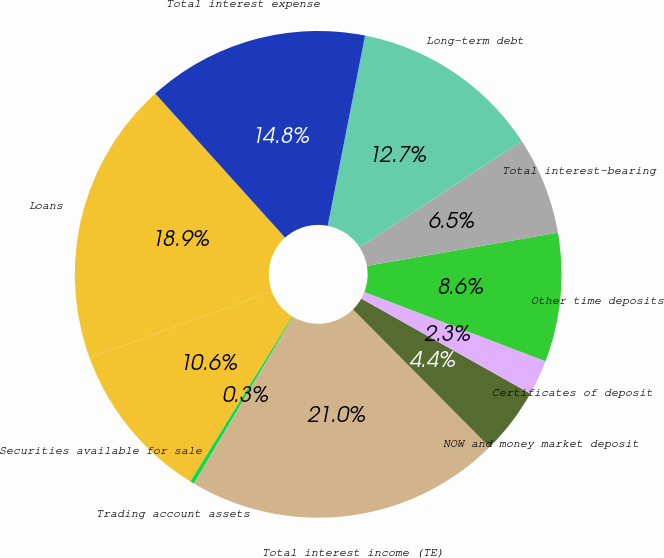Convert chart to OTSL. <chart><loc_0><loc_0><loc_500><loc_500><pie_chart><fcel>Loans<fcel>Securities available for sale<fcel>Trading account assets<fcel>Total interest income (TE)<fcel>NOW and money market deposit<fcel>Certificates of deposit<fcel>Other time deposits<fcel>Total interest-bearing<fcel>Long-term debt<fcel>Total interest expense<nl><fcel>18.9%<fcel>10.62%<fcel>0.27%<fcel>20.97%<fcel>4.41%<fcel>2.34%<fcel>8.55%<fcel>6.48%<fcel>12.69%<fcel>14.76%<nl></chart> 